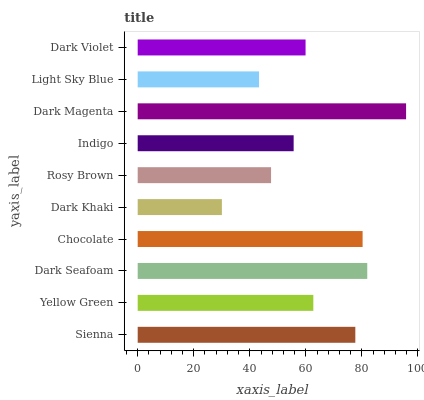Is Dark Khaki the minimum?
Answer yes or no. Yes. Is Dark Magenta the maximum?
Answer yes or no. Yes. Is Yellow Green the minimum?
Answer yes or no. No. Is Yellow Green the maximum?
Answer yes or no. No. Is Sienna greater than Yellow Green?
Answer yes or no. Yes. Is Yellow Green less than Sienna?
Answer yes or no. Yes. Is Yellow Green greater than Sienna?
Answer yes or no. No. Is Sienna less than Yellow Green?
Answer yes or no. No. Is Yellow Green the high median?
Answer yes or no. Yes. Is Dark Violet the low median?
Answer yes or no. Yes. Is Rosy Brown the high median?
Answer yes or no. No. Is Yellow Green the low median?
Answer yes or no. No. 